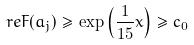Convert formula to latex. <formula><loc_0><loc_0><loc_500><loc_500>\ r e F ( a _ { j } ) \geq \exp \left ( \frac { 1 } { 1 5 } x \right ) \geq c _ { 0 }</formula> 